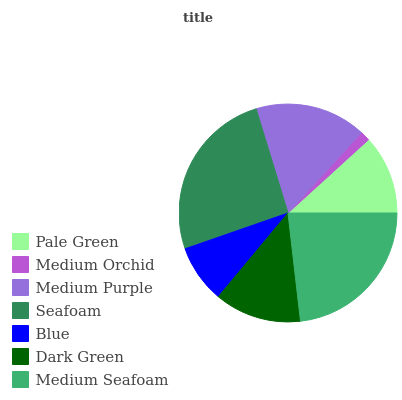Is Medium Orchid the minimum?
Answer yes or no. Yes. Is Seafoam the maximum?
Answer yes or no. Yes. Is Medium Purple the minimum?
Answer yes or no. No. Is Medium Purple the maximum?
Answer yes or no. No. Is Medium Purple greater than Medium Orchid?
Answer yes or no. Yes. Is Medium Orchid less than Medium Purple?
Answer yes or no. Yes. Is Medium Orchid greater than Medium Purple?
Answer yes or no. No. Is Medium Purple less than Medium Orchid?
Answer yes or no. No. Is Dark Green the high median?
Answer yes or no. Yes. Is Dark Green the low median?
Answer yes or no. Yes. Is Medium Orchid the high median?
Answer yes or no. No. Is Medium Seafoam the low median?
Answer yes or no. No. 